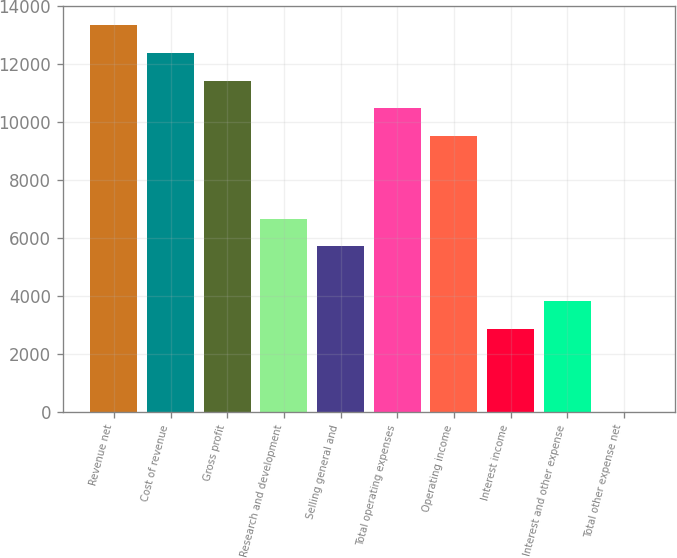<chart> <loc_0><loc_0><loc_500><loc_500><bar_chart><fcel>Revenue net<fcel>Cost of revenue<fcel>Gross profit<fcel>Research and development<fcel>Selling general and<fcel>Total operating expenses<fcel>Operating income<fcel>Interest income<fcel>Interest and other expense<fcel>Total other expense net<nl><fcel>13336<fcel>12383.5<fcel>11431<fcel>6668.5<fcel>5716<fcel>10478.5<fcel>9526<fcel>2858.5<fcel>3811<fcel>1<nl></chart> 